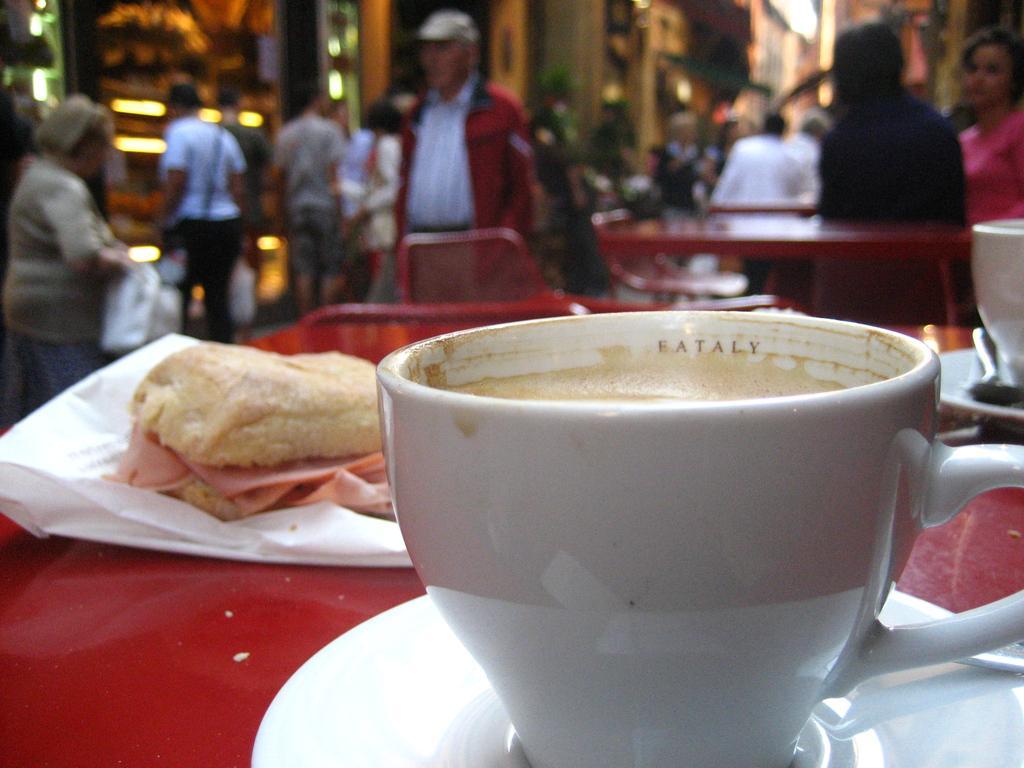In one or two sentences, can you explain what this image depicts? In this image I can see a cup which is in white color, background I can see some food in brown color on the table, and the table is in red color. Background I can see few other persons some are standing and some are sitting. 